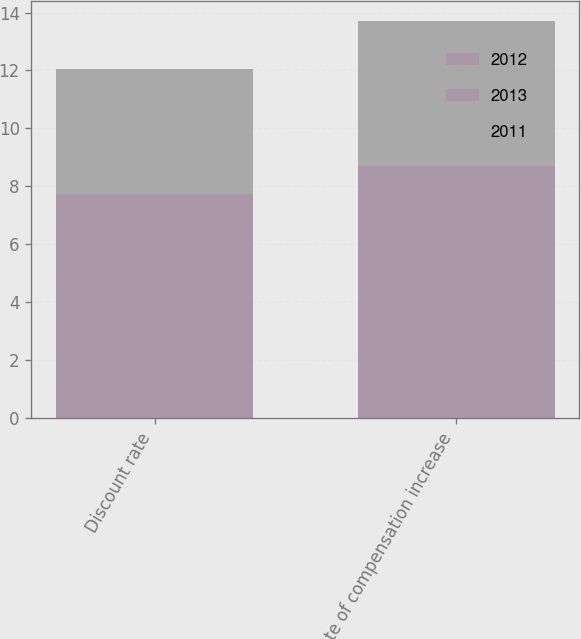<chart> <loc_0><loc_0><loc_500><loc_500><stacked_bar_chart><ecel><fcel>Discount rate<fcel>Rate of compensation increase<nl><fcel>2012<fcel>4.3<fcel>3.7<nl><fcel>2013<fcel>3.45<fcel>5<nl><fcel>2011<fcel>4.3<fcel>5<nl></chart> 